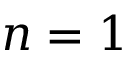Convert formula to latex. <formula><loc_0><loc_0><loc_500><loc_500>n = 1</formula> 